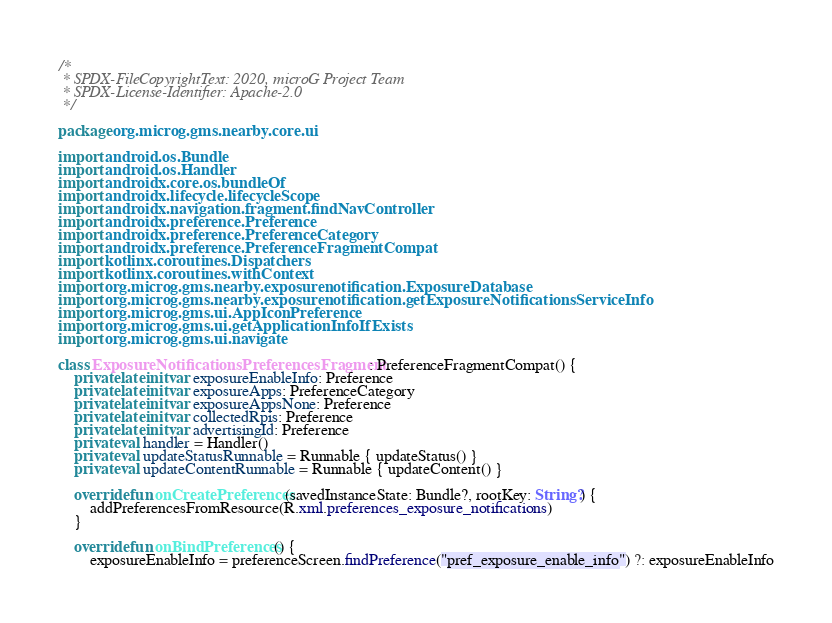<code> <loc_0><loc_0><loc_500><loc_500><_Kotlin_>/*
 * SPDX-FileCopyrightText: 2020, microG Project Team
 * SPDX-License-Identifier: Apache-2.0
 */

package org.microg.gms.nearby.core.ui

import android.os.Bundle
import android.os.Handler
import androidx.core.os.bundleOf
import androidx.lifecycle.lifecycleScope
import androidx.navigation.fragment.findNavController
import androidx.preference.Preference
import androidx.preference.PreferenceCategory
import androidx.preference.PreferenceFragmentCompat
import kotlinx.coroutines.Dispatchers
import kotlinx.coroutines.withContext
import org.microg.gms.nearby.exposurenotification.ExposureDatabase
import org.microg.gms.nearby.exposurenotification.getExposureNotificationsServiceInfo
import org.microg.gms.ui.AppIconPreference
import org.microg.gms.ui.getApplicationInfoIfExists
import org.microg.gms.ui.navigate

class ExposureNotificationsPreferencesFragment : PreferenceFragmentCompat() {
    private lateinit var exposureEnableInfo: Preference
    private lateinit var exposureApps: PreferenceCategory
    private lateinit var exposureAppsNone: Preference
    private lateinit var collectedRpis: Preference
    private lateinit var advertisingId: Preference
    private val handler = Handler()
    private val updateStatusRunnable = Runnable { updateStatus() }
    private val updateContentRunnable = Runnable { updateContent() }

    override fun onCreatePreferences(savedInstanceState: Bundle?, rootKey: String?) {
        addPreferencesFromResource(R.xml.preferences_exposure_notifications)
    }

    override fun onBindPreferences() {
        exposureEnableInfo = preferenceScreen.findPreference("pref_exposure_enable_info") ?: exposureEnableInfo</code> 